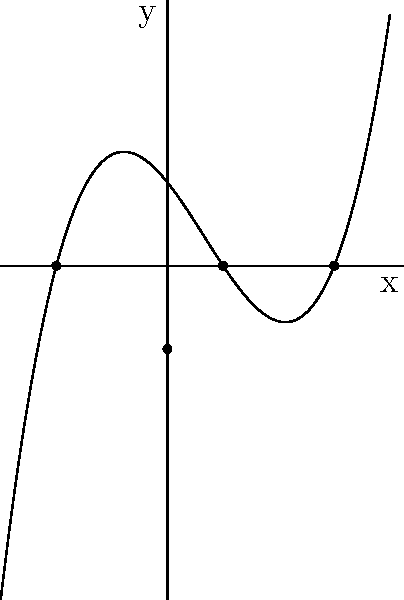Given the graph of a polynomial function that passes through the points $(-2,0)$, $(1,0)$, $(3,0)$, and $(0,-1.5)$, determine the equation of this function. Express your answer in factored form. To find the equation of this polynomial function, we'll follow these steps:

1) The x-intercepts of the function are at $x=-2$, $x=1$, and $x=3$. This means the factors of the polynomial are $(x+2)$, $(x-1)$, and $(x-3)$.

2) The general form of the polynomial will be:
   $f(x) = a(x+2)(x-1)(x-3)$

3) To find the value of $a$, we can use the point $(0,-1.5)$:
   $-1.5 = a(0+2)(0-1)(0-3)$
   $-1.5 = a(2)(-1)(-3)$
   $-1.5 = 6a$

4) Solving for $a$:
   $a = -1.5 / 6 = -0.25$

5) Therefore, the equation of the polynomial function is:
   $f(x) = -0.25(x+2)(x-1)(x-3)$

6) To express this in standard form:
   $f(x) = -0.25(x^3 - 2x^2 - 5x + 6)$

However, the question asks for the factored form, so we'll keep it as in step 5.
Answer: $f(x) = -0.25(x+2)(x-1)(x-3)$ 